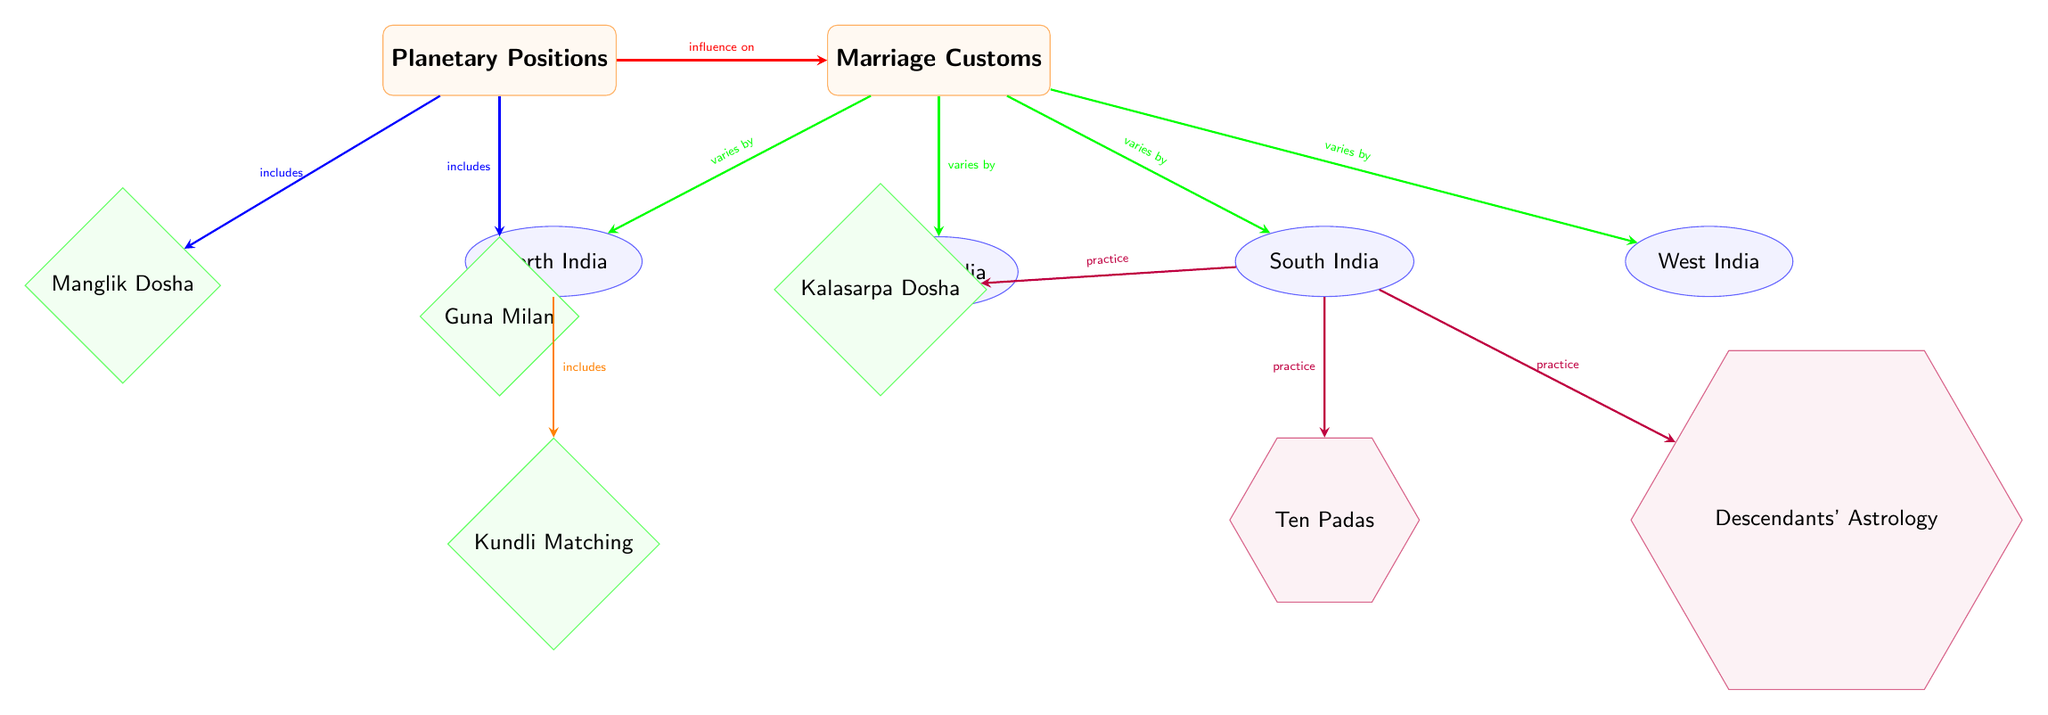What influences marriage customs in the diagram? The diagram shows an arrow from the node "Planetary Positions" to "Marriage Customs," indicating that planetary positions have an influence on marriage customs.
Answer: planetary positions How many regions are depicted in the diagram related to marriage customs? The diagram shows four regions: North India, South India, East India, and West India, all linked to "Marriage Customs."
Answer: four What astrological concept is specific to North India in the context of marriage? The diagram indicates that "Kundli Matching" is specifically associated with North India by an arrow labeled "includes."
Answer: Kundli Matching Which practices are associated with South India based on the diagram? The diagram has arrows showing that "Ten Padas," "Descendants' Astrology," and "Kalasarpa Dosha" are practices related to South India.
Answer: Ten Padas, Descendants' Astrology, Kalasarpa Dosha What is the relationship between planetary positions and marriage customs? The arrow from "Planetary Positions" to "Marriage Customs" signifies that there is an influence of planetary positions on marriage customs.
Answer: influence on What does "Guna Milan" pertain to? As indicated by the arrow from "Planetary Positions," "Guna Milan" is an astrological concept connected to marriage customs.
Answer: astrological concept Which planetary influence is associated with marital issues in some astrological beliefs? The diagram indicates "Manglik Dosha" as one of the astrological concepts, often linked to marital challenges according to astrology.
Answer: Manglik Dosha Which region includes "Guna Milan" in its marriage customs? The diagram does not specify a direct link between "Guna Milan" and a specific region; thus, it can be understood that it applies generally under planetary positions.
Answer: not specified How do marriage customs vary across the regions in the diagram? The arrows from "Marriage Customs" to the four regions signify that marriage customs vary based on the type of region in India depicted.
Answer: varies by region 